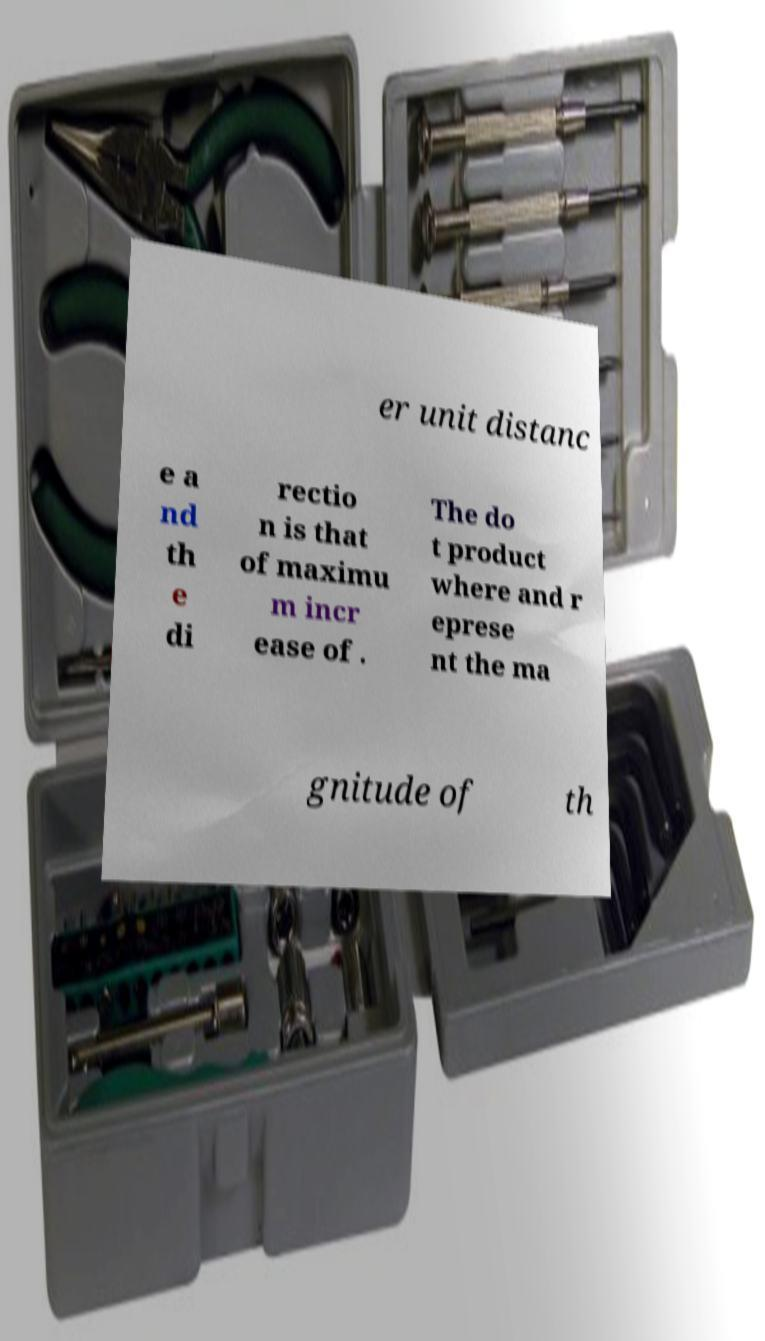Please read and relay the text visible in this image. What does it say? er unit distanc e a nd th e di rectio n is that of maximu m incr ease of . The do t product where and r eprese nt the ma gnitude of th 